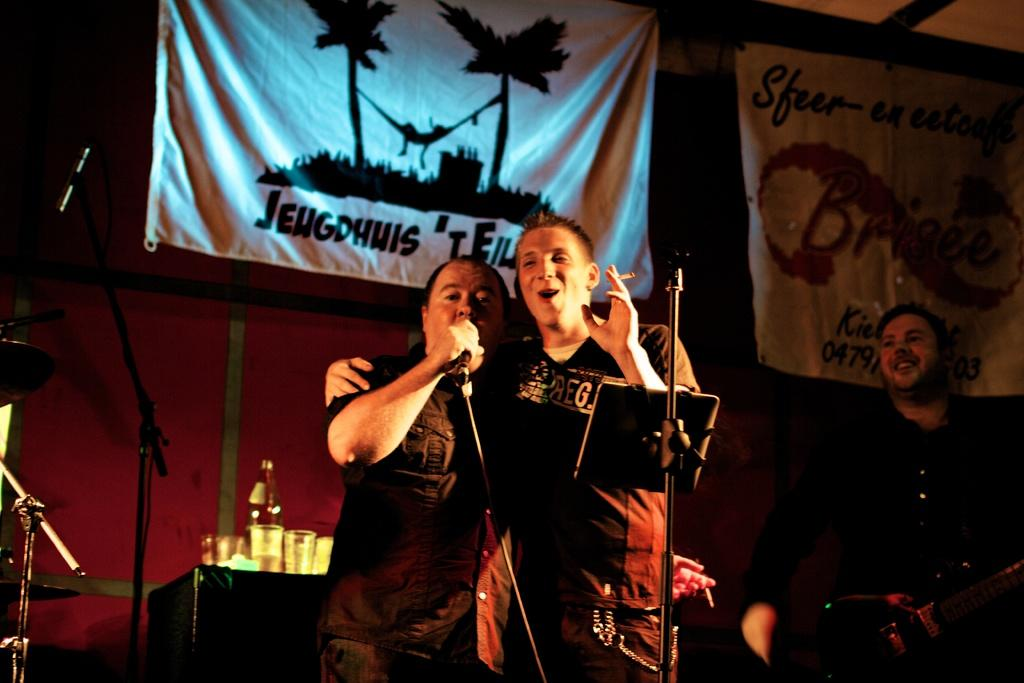How many people are present in the image? There are two people standing in the image. What is one of the people holding? One of the people is holding a microphone. What is the person with the microphone doing? The person with the microphone is singing. Can you describe the person on the left side of the image? The person on the left side of the image is holding a guitar. What type of kettle is being used to record the performance in the image? There is no kettle present in the image, and no recording is taking place. 